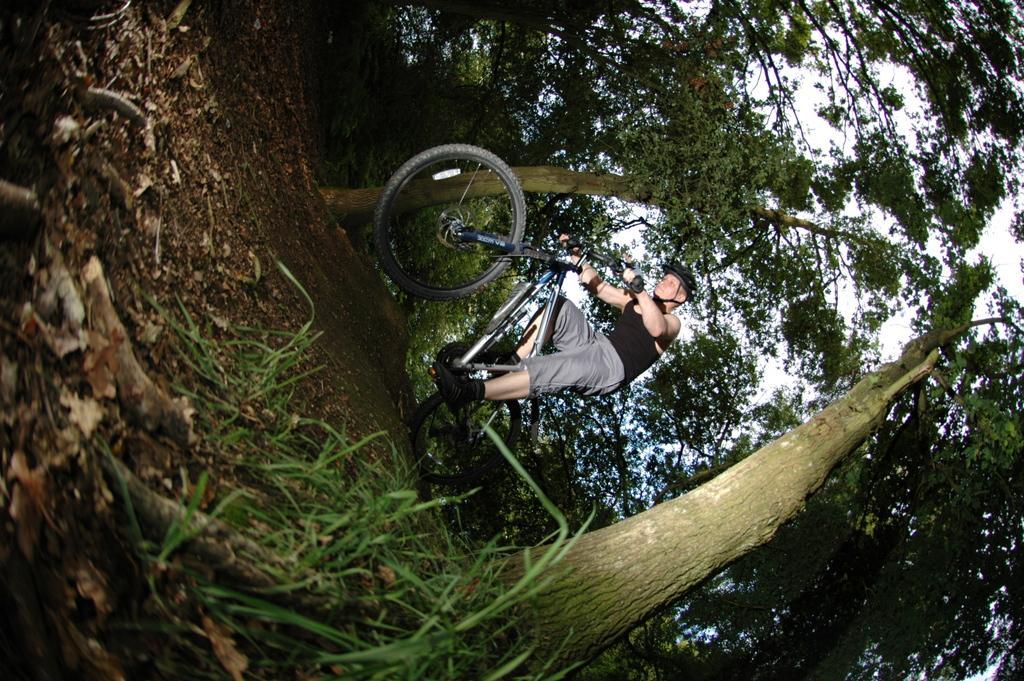How would you summarize this image in a sentence or two? In this image we can see a person wearing a helmet is riding a bicycle on the ground. In the background, we can see a group of trees and sky. 